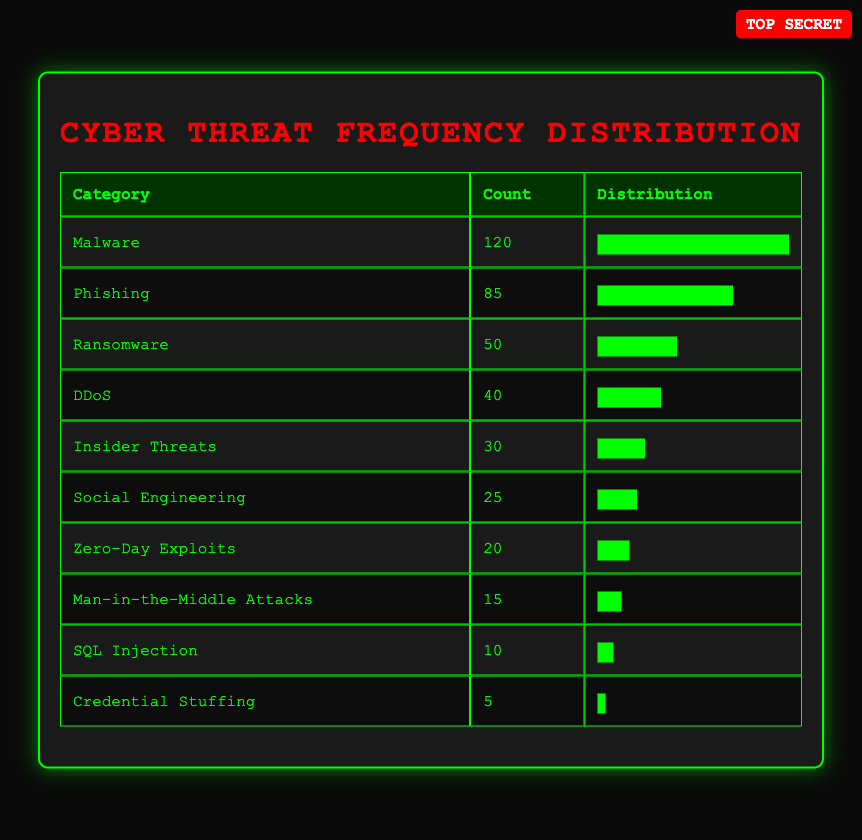What category has the highest count of detected cyber threats? The table lists categories of cyber threats along with their counts. By comparing the counts, "Malware" has the highest count at 120.
Answer: Malware What is the total count of cyber threats categorized as "Phishing" and "Ransomware"? To find the total count, I add the counts for "Phishing" (85) and "Ransomware" (50). So, 85 + 50 = 135.
Answer: 135 Are there more "Zero-Day Exploits" detected than "Man-in-the-Middle Attacks"? The counts for "Zero-Day Exploits" is 20 and for "Man-in-the-Middle Attacks" it is 15. Since 20 is greater than 15, the statement is true.
Answer: Yes What percentage of the total detected cyber threats does "Social Engineering" represent? The total counts of all threats is calculated as 120 + 85 + 50 + 40 + 30 + 20 + 15 + 10 + 5 + 25 = 420. The count for "Social Engineering" is 25. To get the percentage, (25 / 420) * 100 = 5.95%.
Answer: 5.95% What is the difference in counts between "Insider Threats" and "DDoS"? The count for "Insider Threats" is 30 and for "DDoS" it is 40. The difference is calculated as 40 - 30 = 10.
Answer: 10 What is the average count of the cyber threat categories listed? The total sum of counts is 420, and there are 10 categories. The average is 420 / 10 = 42.
Answer: 42 Is the count of "Credential Stuffing" higher than "SQL Injection"? The count for "Credential Stuffing" is 5 and for "SQL Injection" it is 10. Since 5 is not greater than 10, the statement is false.
Answer: No Which category's count ranks fifth in the table? The categories can be ranked based on their counts from highest to lowest. After ranking, the fifth category is "Insider Threats" with a count of 30.
Answer: Insider Threats 